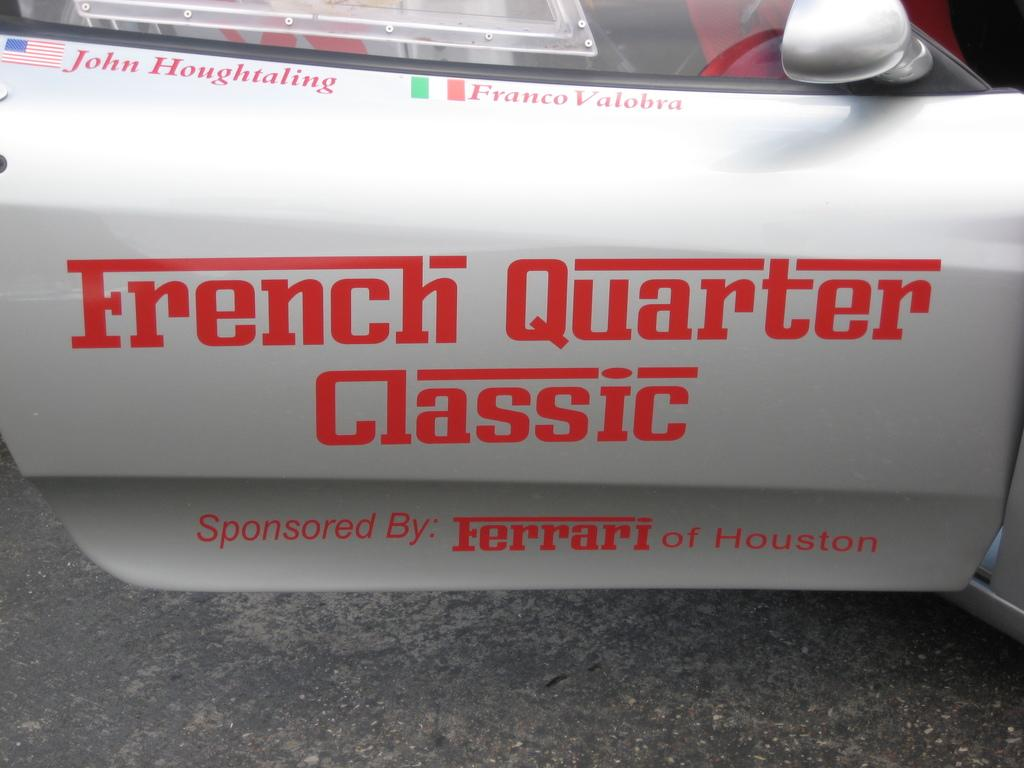What is the main object in the image? There is a car door in the image. What can be seen on the car door? The car door has text written on it. What does the text say? The text includes "French Quarter Classic Sponsored by Ferrari by Houston." What flavor of apples is being advertised on the car door? There is no mention of apples or any flavors in the text on the car door. 